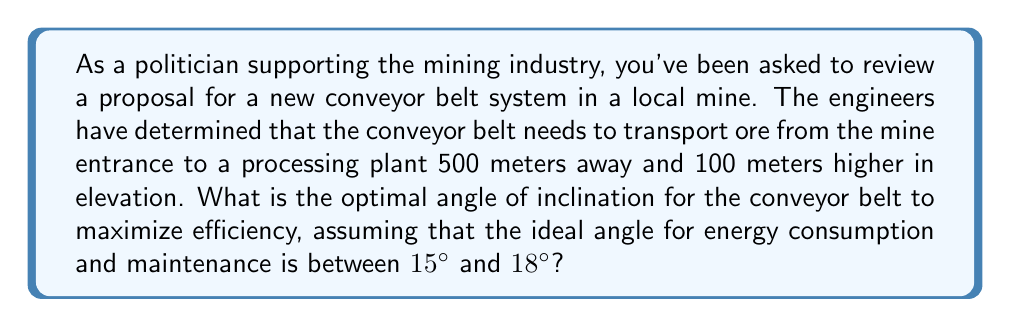What is the answer to this math problem? To solve this problem, we need to use trigonometry to calculate the angle of inclination and then determine if it falls within the optimal range.

Let's break it down step-by-step:

1. First, we need to identify the components of the right triangle formed by the conveyor belt:
   - The horizontal distance (adjacent side) is 500 meters
   - The vertical distance (opposite side) is 100 meters
   - The conveyor belt forms the hypotenuse

2. We can use the tangent function to find the angle of inclination:

   $$\tan \theta = \frac{\text{opposite}}{\text{adjacent}} = \frac{\text{vertical rise}}{\text{horizontal distance}}$$

3. Substituting our values:

   $$\tan \theta = \frac{100}{500} = 0.2$$

4. To find the angle, we need to use the inverse tangent (arctan or $\tan^{-1}$):

   $$\theta = \tan^{-1}(0.2)$$

5. Using a calculator or trigonometric tables:

   $$\theta \approx 11.31°$$

6. Now, we need to compare this result with the ideal range of 15° to 18°.

The calculated angle (11.31°) is less than the ideal range. Therefore, the optimal angle for efficiency would be the lower bound of the ideal range, which is 15°.

[asy]
import geometry;

size(200);
pair A = (0,0);
pair B = (10,2);
pair C = (10,0);

draw(A--B--C--A);
draw(A--B,arrow=Arrow(TeXHead));

label("500 m", C, S);
label("100 m", B, E);
label("Conveyor Belt", (5,1.3), NW);

markangle("15°", radius=0.8, A, C, B);
[/asy]
Answer: The optimal angle for the conveyor belt to maximize efficiency is 15°. 